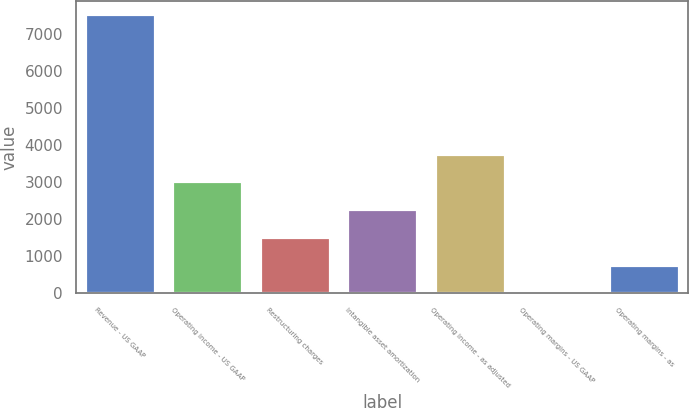Convert chart. <chart><loc_0><loc_0><loc_500><loc_500><bar_chart><fcel>Revenue - US GAAP<fcel>Operating income - US GAAP<fcel>Restructuring charges<fcel>Intangible asset amortization<fcel>Operating income - as adjusted<fcel>Operating margins - US GAAP<fcel>Operating margins - as<nl><fcel>7537<fcel>3026.02<fcel>1522.36<fcel>2274.19<fcel>3777.85<fcel>18.7<fcel>770.53<nl></chart> 